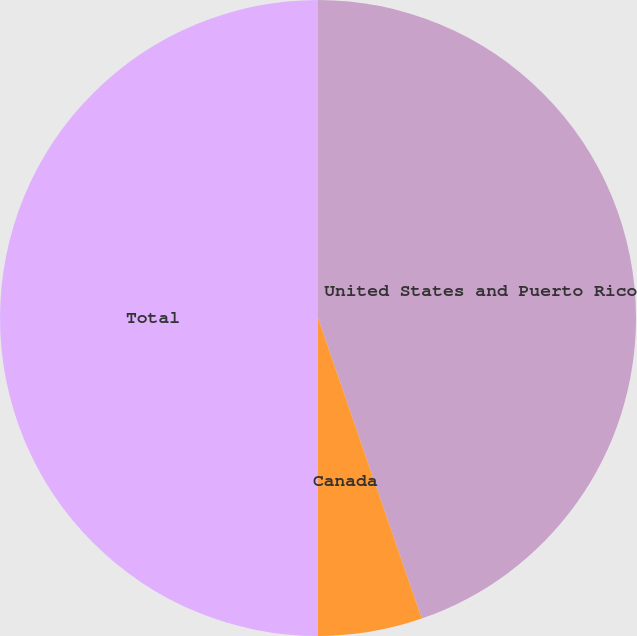<chart> <loc_0><loc_0><loc_500><loc_500><pie_chart><fcel>United States and Puerto Rico<fcel>Canada<fcel>Total<nl><fcel>44.71%<fcel>5.29%<fcel>50.0%<nl></chart> 